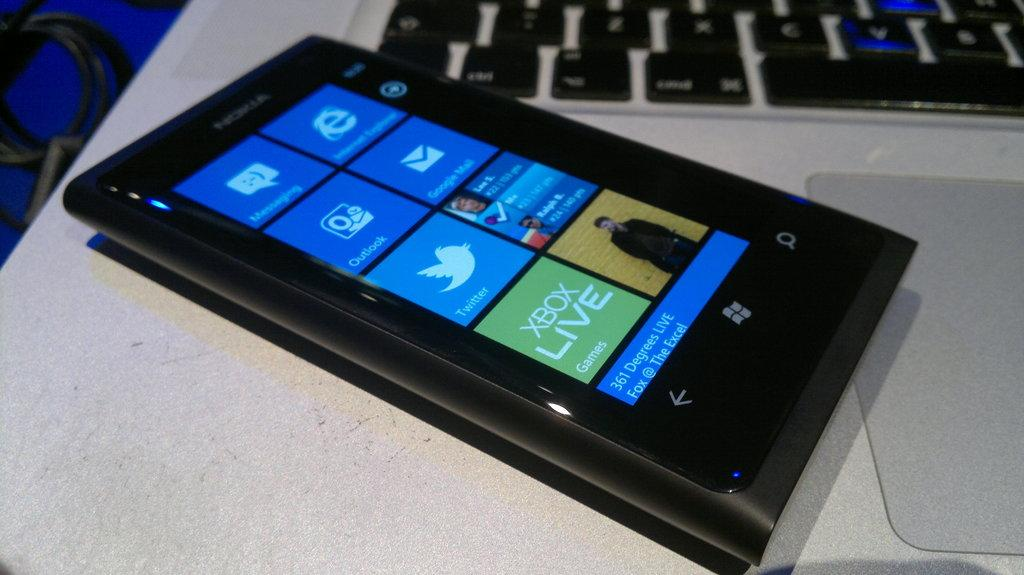What type of furniture is present in the image? There is a table in the image. What electronic device can be seen on the table? There is a mobile phone on the table. What is covering the table in the image? There is a mat on the table. What type of input device is on the table? There is a keyboard on the table. Who is the creator of the watch in the image? There is no watch present in the image. 